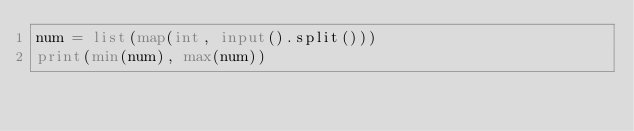<code> <loc_0><loc_0><loc_500><loc_500><_Python_>num = list(map(int, input().split()))
print(min(num), max(num))
</code> 